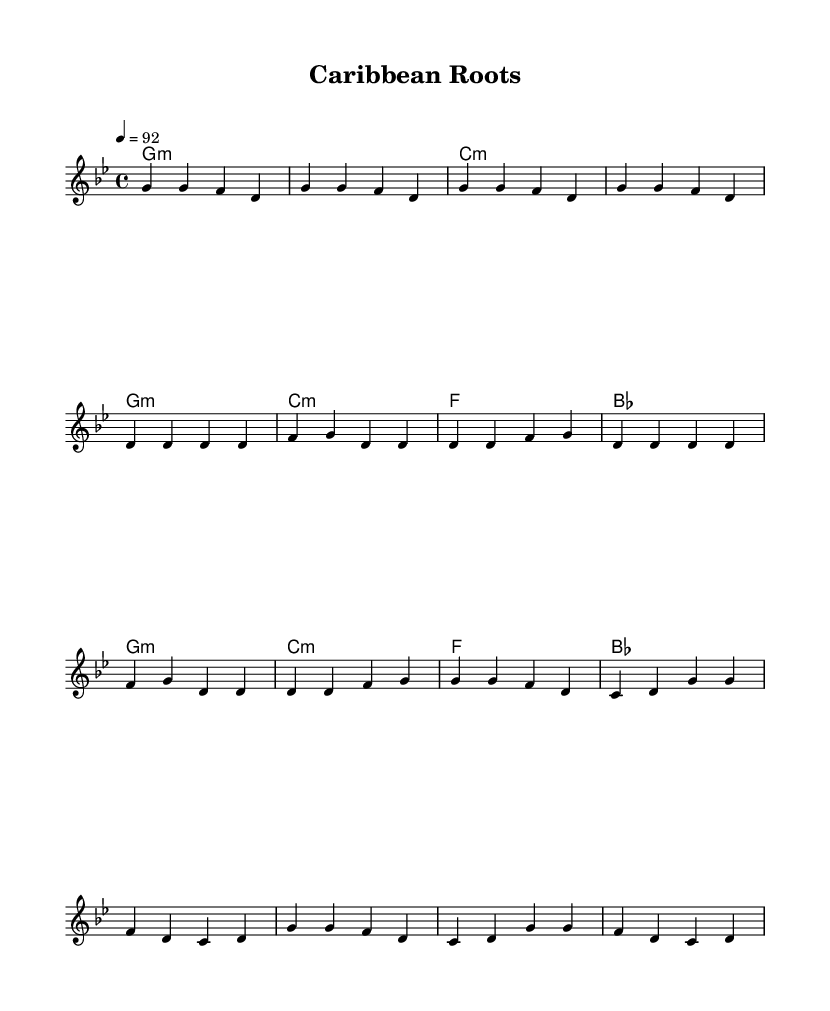What is the key signature of this music? The key signature is G minor, which indicates the presence of two flats. This can be confirmed by examining the key signature notations on the staff in the music.
Answer: G minor What is the time signature of this music? The time signature is 4/4, which is indicated at the beginning of the score. This means there are four beats in each measure and the quarter note gets the beat.
Answer: 4/4 What is the tempo marking of this piece? The tempo marking is 92 beats per minute, as indicated by the tempo notation in the score. This tells us the speed at which the music should be played.
Answer: 92 How many measures are in the Intro section? The Intro consists of four measures, which can be counted by measuring the number of bar lines present before the first chord change.
Answer: Four measures What chord comes after the second verse in the piece? The chord that follows the second verse is F major. This chord can be deduced by looking closely at the chord changes listed along with the melody.
Answer: F What is the style this music is written for? This music is written for the Rap genre, which is indicated by the rhythmic style and the content focus, reflecting Caribbean history and culture. The structured verses and chorus are characteristic of rap music.
Answer: Rap What is the final chord type in the chorus section? The final chord type in the chorus is B flat major. This chord can be discerned from the chord indication in the score for the last measure of the chorus section.
Answer: B flat major 